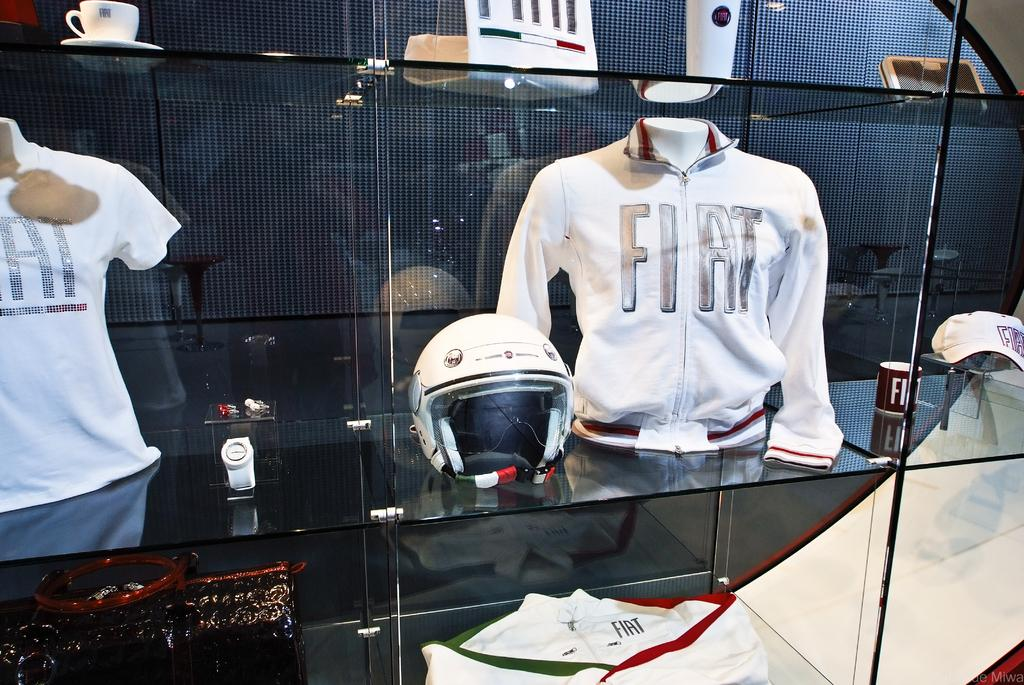What is the main object in the image? There is a glass rack in the image. What items can be seen on the glass rack? A t-shirt, a helmet, a jacket, a cup, and a saucer are on the glass rack. Are there any other items on the glass rack besides the ones mentioned? Yes, there are other few things on the glass rack. What type of canvas is being used to paint the mark on the t-shirt in the image? There is no canvas or painting activity present in the image. The t-shirt is simply hanging on the glass rack. 